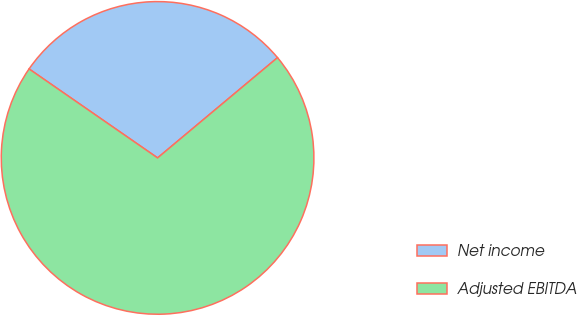<chart> <loc_0><loc_0><loc_500><loc_500><pie_chart><fcel>Net income<fcel>Adjusted EBITDA<nl><fcel>29.28%<fcel>70.72%<nl></chart> 